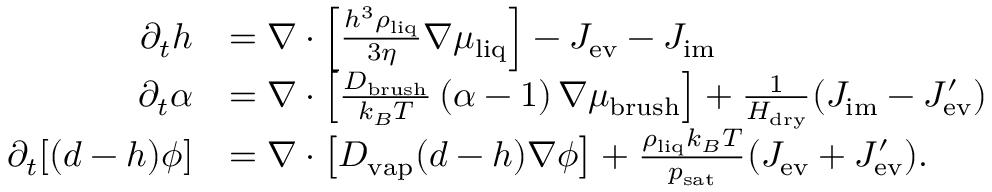<formula> <loc_0><loc_0><loc_500><loc_500>\begin{array} { r l } { \partial _ { t } h } & { = \nabla \cdot \left [ \frac { h ^ { 3 } \rho _ { l i q } } { 3 \eta } \nabla \mu _ { l i q } \right ] - J _ { e v } - J _ { i m } } \\ { \partial _ { t } \alpha } & { = \nabla \cdot \left [ \frac { D _ { b r u s h } } { k _ { B } T } \, ( \alpha - 1 ) \, \nabla \mu _ { b r u s h } \right ] + \frac { 1 } { H _ { d r y } } ( J _ { i m } - J _ { e v } ^ { \prime } ) } \\ { \partial _ { t } [ ( d - h ) \phi ] } & { = \nabla \cdot \left [ D _ { v a p } ( d - h ) \nabla \phi \right ] + \frac { \rho _ { l i q } k _ { B } T } { p _ { s a t } } ( J _ { e v } + J _ { e v } ^ { \prime } ) . } \end{array}</formula> 